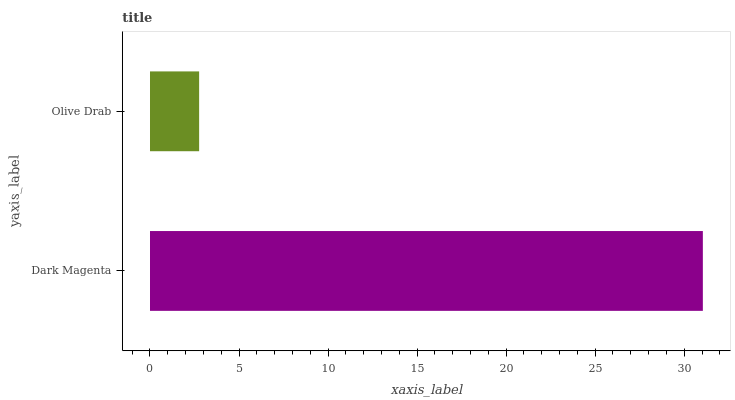Is Olive Drab the minimum?
Answer yes or no. Yes. Is Dark Magenta the maximum?
Answer yes or no. Yes. Is Olive Drab the maximum?
Answer yes or no. No. Is Dark Magenta greater than Olive Drab?
Answer yes or no. Yes. Is Olive Drab less than Dark Magenta?
Answer yes or no. Yes. Is Olive Drab greater than Dark Magenta?
Answer yes or no. No. Is Dark Magenta less than Olive Drab?
Answer yes or no. No. Is Dark Magenta the high median?
Answer yes or no. Yes. Is Olive Drab the low median?
Answer yes or no. Yes. Is Olive Drab the high median?
Answer yes or no. No. Is Dark Magenta the low median?
Answer yes or no. No. 